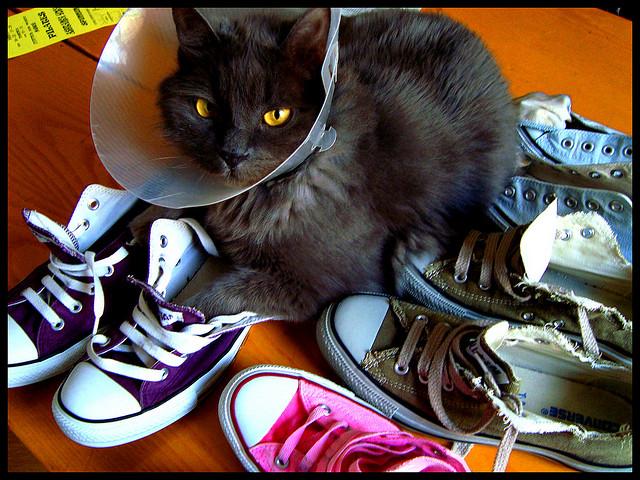What are the brand of shoes?
Quick response, please. Converse. How many sneakers are there?
Keep it brief. 7. What color is the cat?
Keep it brief. Black. 